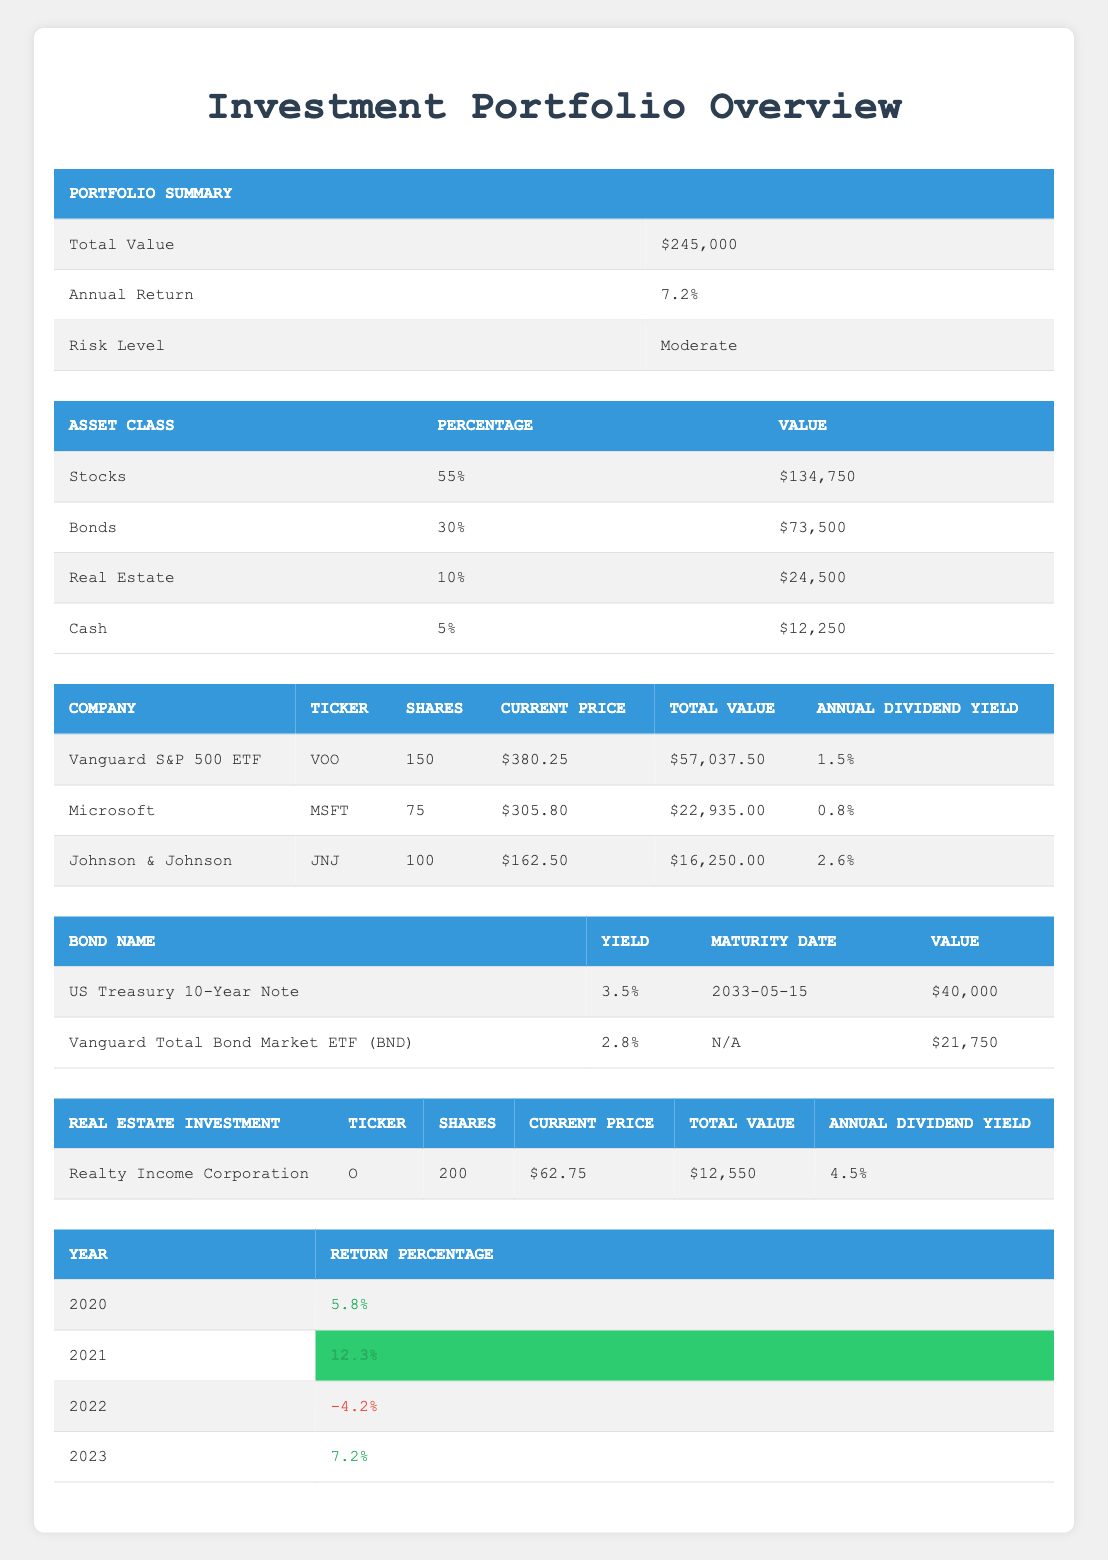What is the total value of the investment portfolio? The total value of the investment portfolio is explicitly listed in the portfolio summary section of the table. It states "Total Value" as $245,000.
Answer: $245,000 What percentage of the portfolio is allocated to Bonds? The table shows the asset allocation section, listing "Bonds" with a specified percentage of 30%.
Answer: 30% Which asset class has the highest value? The table presents the asset allocation with values next to each asset class. The highest value is for "Stocks," which is $134,750.
Answer: Stocks What is the total annual dividend yield for the stock holdings? To find the total annual dividend yield, I sum up the dividend yields of the three stocks: 1.5% (Vanguard) + 0.8% (Microsoft) + 2.6% (Johnson & Johnson) = 5.9%.
Answer: 5.9% In which year did the portfolio perform the worst? Referring to the performance history table, I look for the year with the lowest return percentage. In 2022, the return percentage was -4.2%, indicating it was the worst year.
Answer: 2022 Is the annual return for 2023 higher than that of 2021? From the performance history, the annual returns are 7.2% for 2023 and 12.3% for 2021. Therefore, 2023's return is lower.
Answer: No What is the value of real estate investments in the portfolio? The value of real estate investments is stated in the asset allocation section as "Real Estate," which amounts to $24,500.
Answer: $24,500 If I wanted to calculate the average return over the years provided, what would it be? To find the average return, I sum all return percentages (5.8 + 12.3 - 4.2 + 7.2 = 21.1) and divide by 4 (the number of years). So, the average return is 21.1 / 4 = 5.275%.
Answer: 5.275% Does the bond holding of US Treasury have a higher yield than the Vanguard Total Bond Market ETF? The US Treasury 10-Year Note has a yield of 3.5%, while the Vanguard Total Bond Market ETF has a yield of 2.8%. Since 3.5% is higher than 2.8%, the statement is true.
Answer: Yes 